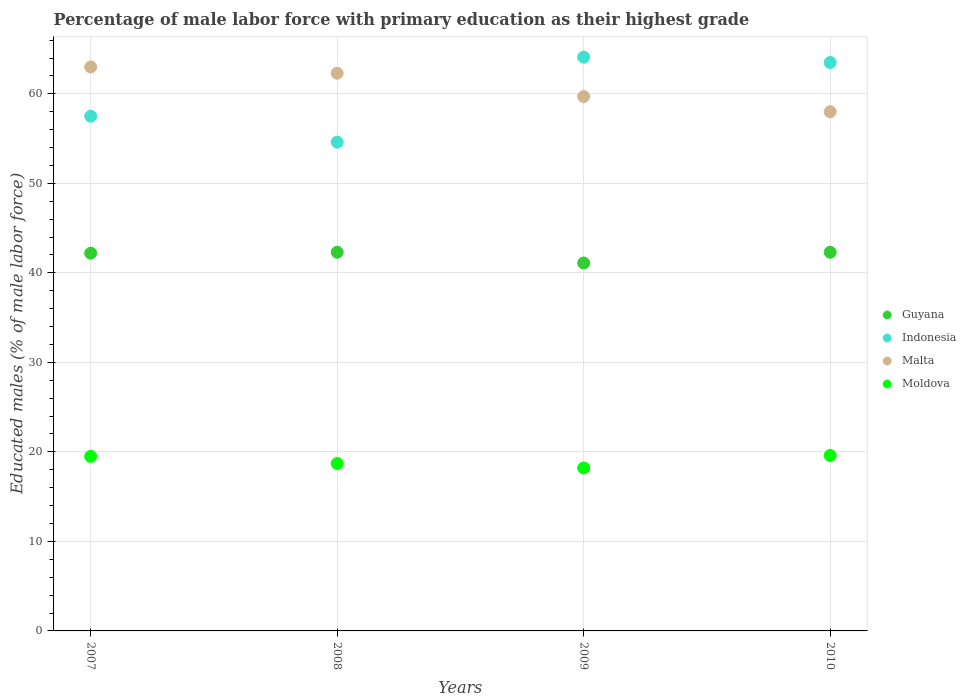How many different coloured dotlines are there?
Your answer should be very brief. 4. What is the percentage of male labor force with primary education in Malta in 2008?
Your response must be concise. 62.3. Across all years, what is the maximum percentage of male labor force with primary education in Moldova?
Give a very brief answer. 19.6. Across all years, what is the minimum percentage of male labor force with primary education in Malta?
Your answer should be very brief. 58. In which year was the percentage of male labor force with primary education in Indonesia maximum?
Keep it short and to the point. 2009. What is the total percentage of male labor force with primary education in Moldova in the graph?
Give a very brief answer. 76. What is the difference between the percentage of male labor force with primary education in Malta in 2007 and that in 2010?
Ensure brevity in your answer.  5. What is the difference between the percentage of male labor force with primary education in Indonesia in 2009 and the percentage of male labor force with primary education in Malta in 2008?
Keep it short and to the point. 1.8. What is the average percentage of male labor force with primary education in Guyana per year?
Make the answer very short. 41.97. In the year 2009, what is the difference between the percentage of male labor force with primary education in Moldova and percentage of male labor force with primary education in Malta?
Offer a terse response. -41.5. What is the ratio of the percentage of male labor force with primary education in Guyana in 2007 to that in 2010?
Provide a succinct answer. 1. What is the difference between the highest and the second highest percentage of male labor force with primary education in Malta?
Ensure brevity in your answer.  0.7. What is the difference between the highest and the lowest percentage of male labor force with primary education in Indonesia?
Your response must be concise. 9.5. Is the sum of the percentage of male labor force with primary education in Indonesia in 2008 and 2009 greater than the maximum percentage of male labor force with primary education in Malta across all years?
Offer a terse response. Yes. Is it the case that in every year, the sum of the percentage of male labor force with primary education in Guyana and percentage of male labor force with primary education in Moldova  is greater than the sum of percentage of male labor force with primary education in Indonesia and percentage of male labor force with primary education in Malta?
Provide a succinct answer. No. Is it the case that in every year, the sum of the percentage of male labor force with primary education in Moldova and percentage of male labor force with primary education in Malta  is greater than the percentage of male labor force with primary education in Indonesia?
Offer a terse response. Yes. Does the percentage of male labor force with primary education in Moldova monotonically increase over the years?
Keep it short and to the point. No. Is the percentage of male labor force with primary education in Moldova strictly greater than the percentage of male labor force with primary education in Indonesia over the years?
Ensure brevity in your answer.  No. Is the percentage of male labor force with primary education in Indonesia strictly less than the percentage of male labor force with primary education in Malta over the years?
Provide a short and direct response. No. How many years are there in the graph?
Make the answer very short. 4. Are the values on the major ticks of Y-axis written in scientific E-notation?
Offer a terse response. No. Does the graph contain grids?
Keep it short and to the point. Yes. Where does the legend appear in the graph?
Your answer should be very brief. Center right. How many legend labels are there?
Your response must be concise. 4. How are the legend labels stacked?
Make the answer very short. Vertical. What is the title of the graph?
Your response must be concise. Percentage of male labor force with primary education as their highest grade. Does "Bhutan" appear as one of the legend labels in the graph?
Your answer should be very brief. No. What is the label or title of the Y-axis?
Offer a terse response. Educated males (% of male labor force). What is the Educated males (% of male labor force) in Guyana in 2007?
Your answer should be very brief. 42.2. What is the Educated males (% of male labor force) of Indonesia in 2007?
Give a very brief answer. 57.5. What is the Educated males (% of male labor force) of Guyana in 2008?
Offer a very short reply. 42.3. What is the Educated males (% of male labor force) of Indonesia in 2008?
Keep it short and to the point. 54.6. What is the Educated males (% of male labor force) in Malta in 2008?
Give a very brief answer. 62.3. What is the Educated males (% of male labor force) of Moldova in 2008?
Offer a very short reply. 18.7. What is the Educated males (% of male labor force) of Guyana in 2009?
Offer a terse response. 41.1. What is the Educated males (% of male labor force) in Indonesia in 2009?
Offer a very short reply. 64.1. What is the Educated males (% of male labor force) in Malta in 2009?
Your response must be concise. 59.7. What is the Educated males (% of male labor force) of Moldova in 2009?
Give a very brief answer. 18.2. What is the Educated males (% of male labor force) of Guyana in 2010?
Your answer should be very brief. 42.3. What is the Educated males (% of male labor force) in Indonesia in 2010?
Your answer should be compact. 63.5. What is the Educated males (% of male labor force) of Moldova in 2010?
Provide a succinct answer. 19.6. Across all years, what is the maximum Educated males (% of male labor force) in Guyana?
Keep it short and to the point. 42.3. Across all years, what is the maximum Educated males (% of male labor force) in Indonesia?
Give a very brief answer. 64.1. Across all years, what is the maximum Educated males (% of male labor force) in Malta?
Make the answer very short. 63. Across all years, what is the maximum Educated males (% of male labor force) in Moldova?
Your response must be concise. 19.6. Across all years, what is the minimum Educated males (% of male labor force) of Guyana?
Provide a succinct answer. 41.1. Across all years, what is the minimum Educated males (% of male labor force) of Indonesia?
Ensure brevity in your answer.  54.6. Across all years, what is the minimum Educated males (% of male labor force) in Malta?
Provide a short and direct response. 58. Across all years, what is the minimum Educated males (% of male labor force) in Moldova?
Your answer should be compact. 18.2. What is the total Educated males (% of male labor force) in Guyana in the graph?
Give a very brief answer. 167.9. What is the total Educated males (% of male labor force) in Indonesia in the graph?
Provide a succinct answer. 239.7. What is the total Educated males (% of male labor force) of Malta in the graph?
Make the answer very short. 243. What is the difference between the Educated males (% of male labor force) of Moldova in 2007 and that in 2008?
Your answer should be compact. 0.8. What is the difference between the Educated males (% of male labor force) of Guyana in 2007 and that in 2009?
Offer a terse response. 1.1. What is the difference between the Educated males (% of male labor force) of Moldova in 2007 and that in 2010?
Give a very brief answer. -0.1. What is the difference between the Educated males (% of male labor force) of Guyana in 2008 and that in 2009?
Offer a very short reply. 1.2. What is the difference between the Educated males (% of male labor force) of Indonesia in 2008 and that in 2010?
Your answer should be compact. -8.9. What is the difference between the Educated males (% of male labor force) in Moldova in 2008 and that in 2010?
Give a very brief answer. -0.9. What is the difference between the Educated males (% of male labor force) of Guyana in 2009 and that in 2010?
Your answer should be compact. -1.2. What is the difference between the Educated males (% of male labor force) in Malta in 2009 and that in 2010?
Ensure brevity in your answer.  1.7. What is the difference between the Educated males (% of male labor force) of Moldova in 2009 and that in 2010?
Provide a short and direct response. -1.4. What is the difference between the Educated males (% of male labor force) of Guyana in 2007 and the Educated males (% of male labor force) of Malta in 2008?
Ensure brevity in your answer.  -20.1. What is the difference between the Educated males (% of male labor force) in Indonesia in 2007 and the Educated males (% of male labor force) in Moldova in 2008?
Ensure brevity in your answer.  38.8. What is the difference between the Educated males (% of male labor force) of Malta in 2007 and the Educated males (% of male labor force) of Moldova in 2008?
Your answer should be compact. 44.3. What is the difference between the Educated males (% of male labor force) in Guyana in 2007 and the Educated males (% of male labor force) in Indonesia in 2009?
Keep it short and to the point. -21.9. What is the difference between the Educated males (% of male labor force) of Guyana in 2007 and the Educated males (% of male labor force) of Malta in 2009?
Give a very brief answer. -17.5. What is the difference between the Educated males (% of male labor force) of Indonesia in 2007 and the Educated males (% of male labor force) of Moldova in 2009?
Keep it short and to the point. 39.3. What is the difference between the Educated males (% of male labor force) of Malta in 2007 and the Educated males (% of male labor force) of Moldova in 2009?
Ensure brevity in your answer.  44.8. What is the difference between the Educated males (% of male labor force) in Guyana in 2007 and the Educated males (% of male labor force) in Indonesia in 2010?
Keep it short and to the point. -21.3. What is the difference between the Educated males (% of male labor force) in Guyana in 2007 and the Educated males (% of male labor force) in Malta in 2010?
Give a very brief answer. -15.8. What is the difference between the Educated males (% of male labor force) in Guyana in 2007 and the Educated males (% of male labor force) in Moldova in 2010?
Offer a terse response. 22.6. What is the difference between the Educated males (% of male labor force) of Indonesia in 2007 and the Educated males (% of male labor force) of Malta in 2010?
Ensure brevity in your answer.  -0.5. What is the difference between the Educated males (% of male labor force) in Indonesia in 2007 and the Educated males (% of male labor force) in Moldova in 2010?
Give a very brief answer. 37.9. What is the difference between the Educated males (% of male labor force) in Malta in 2007 and the Educated males (% of male labor force) in Moldova in 2010?
Make the answer very short. 43.4. What is the difference between the Educated males (% of male labor force) in Guyana in 2008 and the Educated males (% of male labor force) in Indonesia in 2009?
Your answer should be compact. -21.8. What is the difference between the Educated males (% of male labor force) in Guyana in 2008 and the Educated males (% of male labor force) in Malta in 2009?
Provide a short and direct response. -17.4. What is the difference between the Educated males (% of male labor force) of Guyana in 2008 and the Educated males (% of male labor force) of Moldova in 2009?
Offer a terse response. 24.1. What is the difference between the Educated males (% of male labor force) of Indonesia in 2008 and the Educated males (% of male labor force) of Malta in 2009?
Give a very brief answer. -5.1. What is the difference between the Educated males (% of male labor force) in Indonesia in 2008 and the Educated males (% of male labor force) in Moldova in 2009?
Ensure brevity in your answer.  36.4. What is the difference between the Educated males (% of male labor force) of Malta in 2008 and the Educated males (% of male labor force) of Moldova in 2009?
Make the answer very short. 44.1. What is the difference between the Educated males (% of male labor force) in Guyana in 2008 and the Educated males (% of male labor force) in Indonesia in 2010?
Your answer should be very brief. -21.2. What is the difference between the Educated males (% of male labor force) in Guyana in 2008 and the Educated males (% of male labor force) in Malta in 2010?
Give a very brief answer. -15.7. What is the difference between the Educated males (% of male labor force) in Guyana in 2008 and the Educated males (% of male labor force) in Moldova in 2010?
Your response must be concise. 22.7. What is the difference between the Educated males (% of male labor force) in Indonesia in 2008 and the Educated males (% of male labor force) in Moldova in 2010?
Keep it short and to the point. 35. What is the difference between the Educated males (% of male labor force) of Malta in 2008 and the Educated males (% of male labor force) of Moldova in 2010?
Make the answer very short. 42.7. What is the difference between the Educated males (% of male labor force) in Guyana in 2009 and the Educated males (% of male labor force) in Indonesia in 2010?
Give a very brief answer. -22.4. What is the difference between the Educated males (% of male labor force) of Guyana in 2009 and the Educated males (% of male labor force) of Malta in 2010?
Your answer should be compact. -16.9. What is the difference between the Educated males (% of male labor force) of Guyana in 2009 and the Educated males (% of male labor force) of Moldova in 2010?
Keep it short and to the point. 21.5. What is the difference between the Educated males (% of male labor force) in Indonesia in 2009 and the Educated males (% of male labor force) in Moldova in 2010?
Your answer should be very brief. 44.5. What is the difference between the Educated males (% of male labor force) of Malta in 2009 and the Educated males (% of male labor force) of Moldova in 2010?
Your answer should be very brief. 40.1. What is the average Educated males (% of male labor force) in Guyana per year?
Your response must be concise. 41.98. What is the average Educated males (% of male labor force) in Indonesia per year?
Your answer should be very brief. 59.92. What is the average Educated males (% of male labor force) of Malta per year?
Offer a terse response. 60.75. In the year 2007, what is the difference between the Educated males (% of male labor force) in Guyana and Educated males (% of male labor force) in Indonesia?
Provide a succinct answer. -15.3. In the year 2007, what is the difference between the Educated males (% of male labor force) of Guyana and Educated males (% of male labor force) of Malta?
Offer a very short reply. -20.8. In the year 2007, what is the difference between the Educated males (% of male labor force) of Guyana and Educated males (% of male labor force) of Moldova?
Make the answer very short. 22.7. In the year 2007, what is the difference between the Educated males (% of male labor force) of Indonesia and Educated males (% of male labor force) of Moldova?
Your answer should be very brief. 38. In the year 2007, what is the difference between the Educated males (% of male labor force) in Malta and Educated males (% of male labor force) in Moldova?
Your response must be concise. 43.5. In the year 2008, what is the difference between the Educated males (% of male labor force) of Guyana and Educated males (% of male labor force) of Moldova?
Ensure brevity in your answer.  23.6. In the year 2008, what is the difference between the Educated males (% of male labor force) in Indonesia and Educated males (% of male labor force) in Moldova?
Provide a succinct answer. 35.9. In the year 2008, what is the difference between the Educated males (% of male labor force) of Malta and Educated males (% of male labor force) of Moldova?
Make the answer very short. 43.6. In the year 2009, what is the difference between the Educated males (% of male labor force) of Guyana and Educated males (% of male labor force) of Indonesia?
Offer a very short reply. -23. In the year 2009, what is the difference between the Educated males (% of male labor force) in Guyana and Educated males (% of male labor force) in Malta?
Ensure brevity in your answer.  -18.6. In the year 2009, what is the difference between the Educated males (% of male labor force) of Guyana and Educated males (% of male labor force) of Moldova?
Ensure brevity in your answer.  22.9. In the year 2009, what is the difference between the Educated males (% of male labor force) of Indonesia and Educated males (% of male labor force) of Moldova?
Keep it short and to the point. 45.9. In the year 2009, what is the difference between the Educated males (% of male labor force) of Malta and Educated males (% of male labor force) of Moldova?
Make the answer very short. 41.5. In the year 2010, what is the difference between the Educated males (% of male labor force) of Guyana and Educated males (% of male labor force) of Indonesia?
Keep it short and to the point. -21.2. In the year 2010, what is the difference between the Educated males (% of male labor force) in Guyana and Educated males (% of male labor force) in Malta?
Ensure brevity in your answer.  -15.7. In the year 2010, what is the difference between the Educated males (% of male labor force) of Guyana and Educated males (% of male labor force) of Moldova?
Provide a succinct answer. 22.7. In the year 2010, what is the difference between the Educated males (% of male labor force) in Indonesia and Educated males (% of male labor force) in Malta?
Provide a succinct answer. 5.5. In the year 2010, what is the difference between the Educated males (% of male labor force) in Indonesia and Educated males (% of male labor force) in Moldova?
Give a very brief answer. 43.9. In the year 2010, what is the difference between the Educated males (% of male labor force) in Malta and Educated males (% of male labor force) in Moldova?
Offer a very short reply. 38.4. What is the ratio of the Educated males (% of male labor force) in Guyana in 2007 to that in 2008?
Offer a very short reply. 1. What is the ratio of the Educated males (% of male labor force) in Indonesia in 2007 to that in 2008?
Offer a terse response. 1.05. What is the ratio of the Educated males (% of male labor force) in Malta in 2007 to that in 2008?
Ensure brevity in your answer.  1.01. What is the ratio of the Educated males (% of male labor force) of Moldova in 2007 to that in 2008?
Give a very brief answer. 1.04. What is the ratio of the Educated males (% of male labor force) in Guyana in 2007 to that in 2009?
Keep it short and to the point. 1.03. What is the ratio of the Educated males (% of male labor force) in Indonesia in 2007 to that in 2009?
Your answer should be compact. 0.9. What is the ratio of the Educated males (% of male labor force) in Malta in 2007 to that in 2009?
Offer a very short reply. 1.06. What is the ratio of the Educated males (% of male labor force) in Moldova in 2007 to that in 2009?
Your answer should be compact. 1.07. What is the ratio of the Educated males (% of male labor force) in Indonesia in 2007 to that in 2010?
Ensure brevity in your answer.  0.91. What is the ratio of the Educated males (% of male labor force) of Malta in 2007 to that in 2010?
Your answer should be compact. 1.09. What is the ratio of the Educated males (% of male labor force) in Moldova in 2007 to that in 2010?
Make the answer very short. 0.99. What is the ratio of the Educated males (% of male labor force) of Guyana in 2008 to that in 2009?
Your response must be concise. 1.03. What is the ratio of the Educated males (% of male labor force) in Indonesia in 2008 to that in 2009?
Offer a very short reply. 0.85. What is the ratio of the Educated males (% of male labor force) of Malta in 2008 to that in 2009?
Provide a short and direct response. 1.04. What is the ratio of the Educated males (% of male labor force) of Moldova in 2008 to that in 2009?
Keep it short and to the point. 1.03. What is the ratio of the Educated males (% of male labor force) in Guyana in 2008 to that in 2010?
Ensure brevity in your answer.  1. What is the ratio of the Educated males (% of male labor force) of Indonesia in 2008 to that in 2010?
Your answer should be compact. 0.86. What is the ratio of the Educated males (% of male labor force) of Malta in 2008 to that in 2010?
Give a very brief answer. 1.07. What is the ratio of the Educated males (% of male labor force) of Moldova in 2008 to that in 2010?
Provide a short and direct response. 0.95. What is the ratio of the Educated males (% of male labor force) of Guyana in 2009 to that in 2010?
Provide a succinct answer. 0.97. What is the ratio of the Educated males (% of male labor force) of Indonesia in 2009 to that in 2010?
Your answer should be very brief. 1.01. What is the ratio of the Educated males (% of male labor force) in Malta in 2009 to that in 2010?
Keep it short and to the point. 1.03. What is the ratio of the Educated males (% of male labor force) of Moldova in 2009 to that in 2010?
Provide a short and direct response. 0.93. What is the difference between the highest and the second highest Educated males (% of male labor force) of Indonesia?
Provide a succinct answer. 0.6. What is the difference between the highest and the second highest Educated males (% of male labor force) in Moldova?
Your response must be concise. 0.1. What is the difference between the highest and the lowest Educated males (% of male labor force) in Indonesia?
Your answer should be very brief. 9.5. What is the difference between the highest and the lowest Educated males (% of male labor force) of Malta?
Ensure brevity in your answer.  5. 